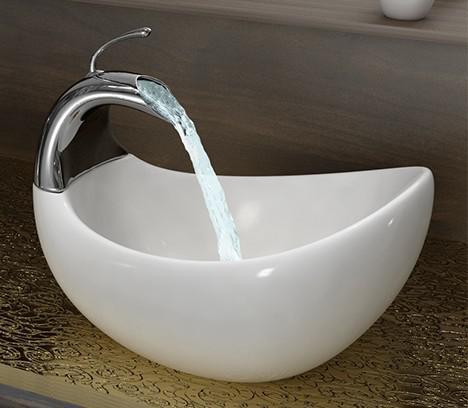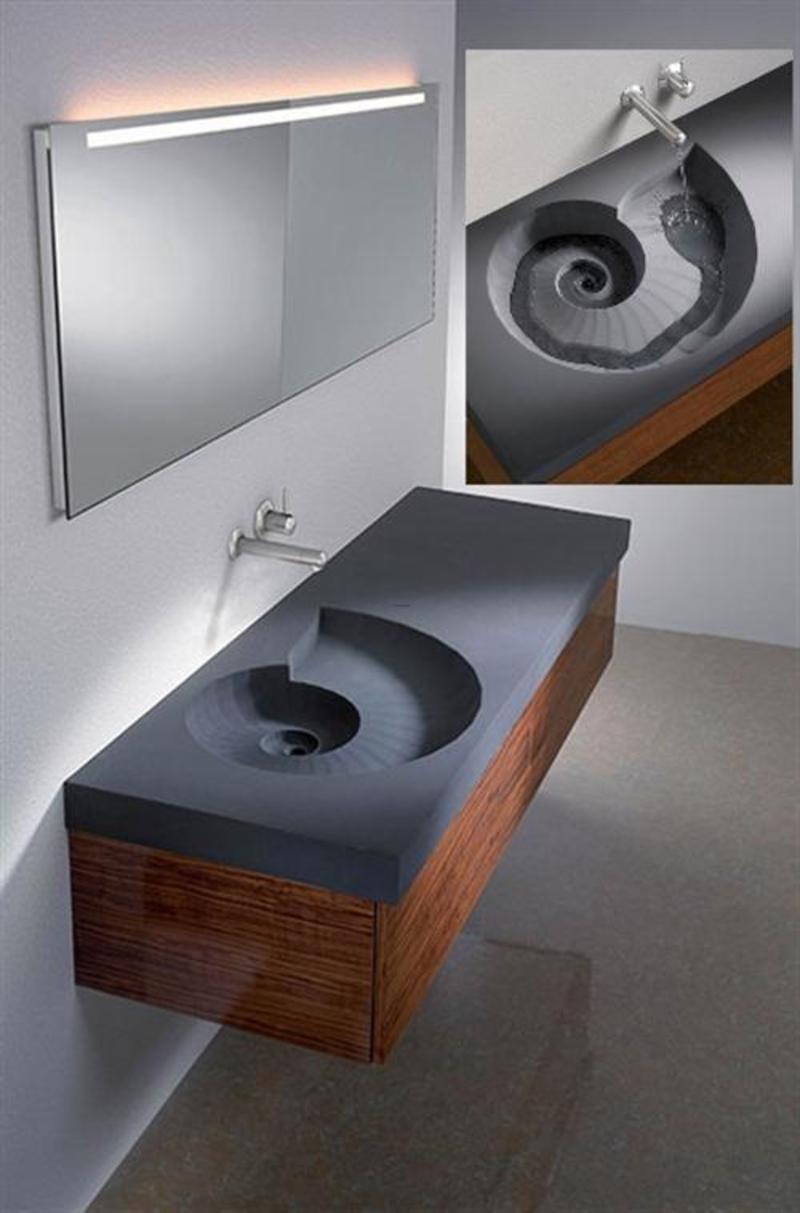The first image is the image on the left, the second image is the image on the right. Evaluate the accuracy of this statement regarding the images: "One wash basin currently contains water.". Is it true? Answer yes or no. Yes. The first image is the image on the left, the second image is the image on the right. Assess this claim about the two images: "The sink on the right has a somewhat spiral shape and has a spout mounted on the wall above it, and the counter-top sink on the left is white and rounded with a silver spout over the basin.". Correct or not? Answer yes or no. Yes. 